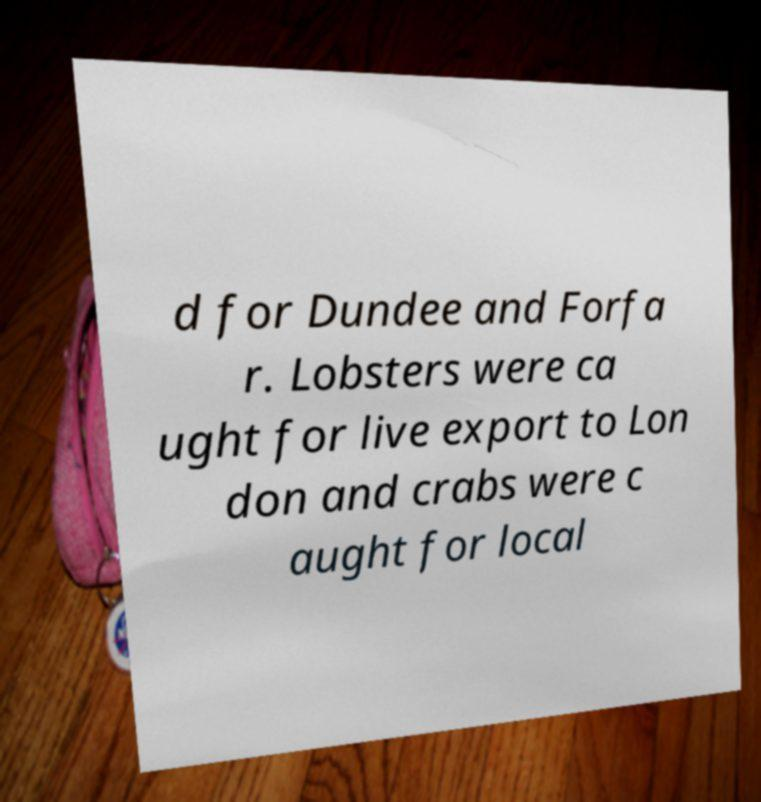Please read and relay the text visible in this image. What does it say? d for Dundee and Forfa r. Lobsters were ca ught for live export to Lon don and crabs were c aught for local 